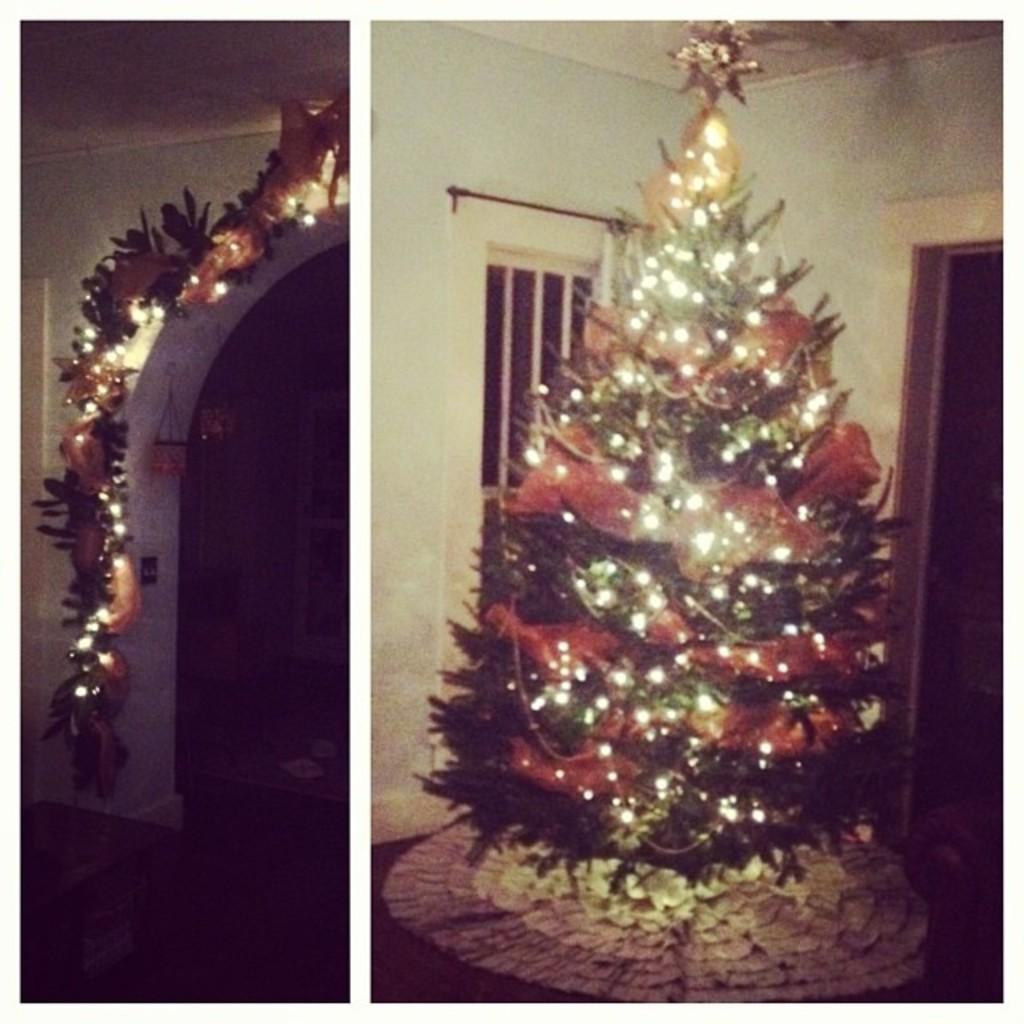How would you summarize this image in a sentence or two? This is a collage picture and in this picture we can see a Christmas tree with lights on it, decorative items, arch, window, walls and some objects. 